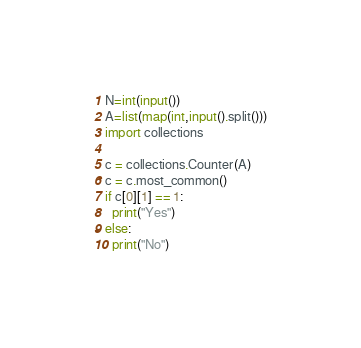Convert code to text. <code><loc_0><loc_0><loc_500><loc_500><_Python_>N=int(input())
A=list(map(int,input().split()))
import collections

c = collections.Counter(A)
c = c.most_common()
if c[0][1] == 1:
  print("Yes")
else:
  print("No")</code> 